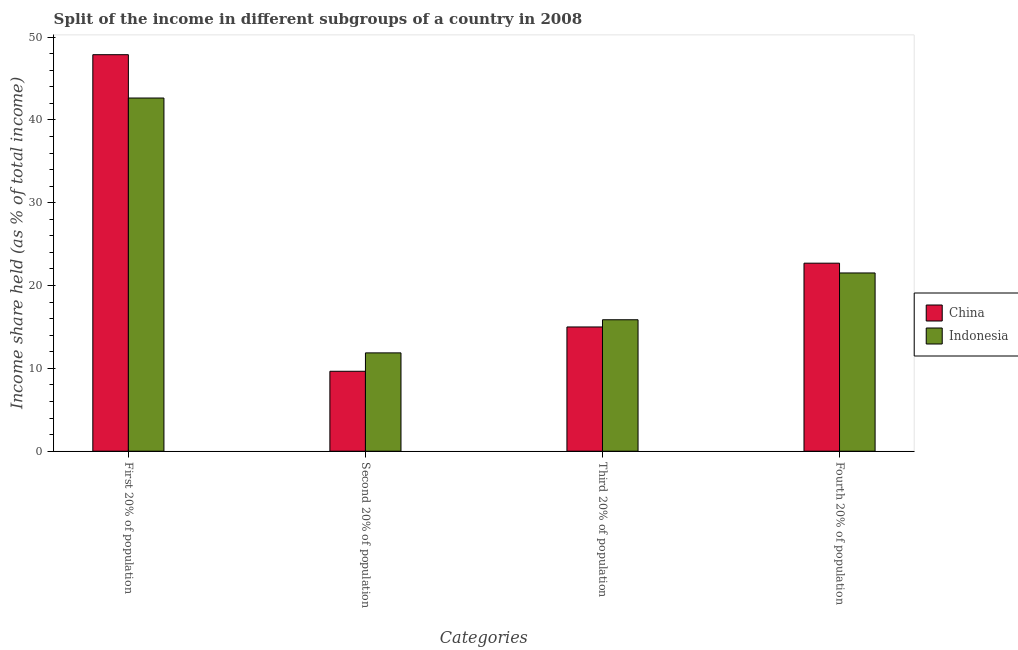How many different coloured bars are there?
Provide a short and direct response. 2. How many groups of bars are there?
Keep it short and to the point. 4. What is the label of the 4th group of bars from the left?
Make the answer very short. Fourth 20% of population. What is the share of the income held by third 20% of the population in Indonesia?
Your answer should be compact. 15.87. Across all countries, what is the maximum share of the income held by third 20% of the population?
Ensure brevity in your answer.  15.87. In which country was the share of the income held by first 20% of the population maximum?
Keep it short and to the point. China. What is the total share of the income held by third 20% of the population in the graph?
Keep it short and to the point. 30.87. What is the difference between the share of the income held by third 20% of the population in Indonesia and that in China?
Offer a very short reply. 0.87. What is the difference between the share of the income held by second 20% of the population in Indonesia and the share of the income held by third 20% of the population in China?
Give a very brief answer. -3.13. What is the average share of the income held by first 20% of the population per country?
Keep it short and to the point. 45.25. What is the difference between the share of the income held by first 20% of the population and share of the income held by fourth 20% of the population in Indonesia?
Give a very brief answer. 21.12. What is the ratio of the share of the income held by third 20% of the population in Indonesia to that in China?
Your answer should be very brief. 1.06. Is the difference between the share of the income held by fourth 20% of the population in Indonesia and China greater than the difference between the share of the income held by third 20% of the population in Indonesia and China?
Offer a very short reply. No. What is the difference between the highest and the second highest share of the income held by second 20% of the population?
Keep it short and to the point. 2.22. What is the difference between the highest and the lowest share of the income held by second 20% of the population?
Provide a short and direct response. 2.22. Is the sum of the share of the income held by first 20% of the population in Indonesia and China greater than the maximum share of the income held by second 20% of the population across all countries?
Your answer should be very brief. Yes. What does the 2nd bar from the left in Second 20% of population represents?
Keep it short and to the point. Indonesia. What does the 1st bar from the right in First 20% of population represents?
Your answer should be compact. Indonesia. Is it the case that in every country, the sum of the share of the income held by first 20% of the population and share of the income held by second 20% of the population is greater than the share of the income held by third 20% of the population?
Provide a short and direct response. Yes. How many bars are there?
Keep it short and to the point. 8. Are all the bars in the graph horizontal?
Keep it short and to the point. No. How many countries are there in the graph?
Make the answer very short. 2. What is the difference between two consecutive major ticks on the Y-axis?
Give a very brief answer. 10. Does the graph contain any zero values?
Ensure brevity in your answer.  No. Does the graph contain grids?
Keep it short and to the point. No. Where does the legend appear in the graph?
Your response must be concise. Center right. How are the legend labels stacked?
Offer a terse response. Vertical. What is the title of the graph?
Ensure brevity in your answer.  Split of the income in different subgroups of a country in 2008. What is the label or title of the X-axis?
Make the answer very short. Categories. What is the label or title of the Y-axis?
Your answer should be very brief. Income share held (as % of total income). What is the Income share held (as % of total income) in China in First 20% of population?
Provide a short and direct response. 47.87. What is the Income share held (as % of total income) of Indonesia in First 20% of population?
Make the answer very short. 42.64. What is the Income share held (as % of total income) of China in Second 20% of population?
Provide a succinct answer. 9.65. What is the Income share held (as % of total income) of Indonesia in Second 20% of population?
Give a very brief answer. 11.87. What is the Income share held (as % of total income) of Indonesia in Third 20% of population?
Offer a very short reply. 15.87. What is the Income share held (as % of total income) of China in Fourth 20% of population?
Offer a terse response. 22.7. What is the Income share held (as % of total income) of Indonesia in Fourth 20% of population?
Provide a short and direct response. 21.52. Across all Categories, what is the maximum Income share held (as % of total income) in China?
Provide a short and direct response. 47.87. Across all Categories, what is the maximum Income share held (as % of total income) of Indonesia?
Offer a very short reply. 42.64. Across all Categories, what is the minimum Income share held (as % of total income) in China?
Provide a succinct answer. 9.65. Across all Categories, what is the minimum Income share held (as % of total income) of Indonesia?
Keep it short and to the point. 11.87. What is the total Income share held (as % of total income) in China in the graph?
Keep it short and to the point. 95.22. What is the total Income share held (as % of total income) of Indonesia in the graph?
Your answer should be compact. 91.9. What is the difference between the Income share held (as % of total income) of China in First 20% of population and that in Second 20% of population?
Give a very brief answer. 38.22. What is the difference between the Income share held (as % of total income) in Indonesia in First 20% of population and that in Second 20% of population?
Keep it short and to the point. 30.77. What is the difference between the Income share held (as % of total income) of China in First 20% of population and that in Third 20% of population?
Provide a succinct answer. 32.87. What is the difference between the Income share held (as % of total income) in Indonesia in First 20% of population and that in Third 20% of population?
Offer a very short reply. 26.77. What is the difference between the Income share held (as % of total income) of China in First 20% of population and that in Fourth 20% of population?
Offer a very short reply. 25.17. What is the difference between the Income share held (as % of total income) of Indonesia in First 20% of population and that in Fourth 20% of population?
Ensure brevity in your answer.  21.12. What is the difference between the Income share held (as % of total income) of China in Second 20% of population and that in Third 20% of population?
Give a very brief answer. -5.35. What is the difference between the Income share held (as % of total income) in China in Second 20% of population and that in Fourth 20% of population?
Offer a terse response. -13.05. What is the difference between the Income share held (as % of total income) of Indonesia in Second 20% of population and that in Fourth 20% of population?
Provide a succinct answer. -9.65. What is the difference between the Income share held (as % of total income) in Indonesia in Third 20% of population and that in Fourth 20% of population?
Your answer should be compact. -5.65. What is the difference between the Income share held (as % of total income) of China in First 20% of population and the Income share held (as % of total income) of Indonesia in Fourth 20% of population?
Offer a terse response. 26.35. What is the difference between the Income share held (as % of total income) in China in Second 20% of population and the Income share held (as % of total income) in Indonesia in Third 20% of population?
Make the answer very short. -6.22. What is the difference between the Income share held (as % of total income) in China in Second 20% of population and the Income share held (as % of total income) in Indonesia in Fourth 20% of population?
Offer a very short reply. -11.87. What is the difference between the Income share held (as % of total income) of China in Third 20% of population and the Income share held (as % of total income) of Indonesia in Fourth 20% of population?
Give a very brief answer. -6.52. What is the average Income share held (as % of total income) of China per Categories?
Your response must be concise. 23.8. What is the average Income share held (as % of total income) of Indonesia per Categories?
Provide a succinct answer. 22.98. What is the difference between the Income share held (as % of total income) in China and Income share held (as % of total income) in Indonesia in First 20% of population?
Make the answer very short. 5.23. What is the difference between the Income share held (as % of total income) in China and Income share held (as % of total income) in Indonesia in Second 20% of population?
Provide a succinct answer. -2.22. What is the difference between the Income share held (as % of total income) of China and Income share held (as % of total income) of Indonesia in Third 20% of population?
Ensure brevity in your answer.  -0.87. What is the difference between the Income share held (as % of total income) in China and Income share held (as % of total income) in Indonesia in Fourth 20% of population?
Your response must be concise. 1.18. What is the ratio of the Income share held (as % of total income) of China in First 20% of population to that in Second 20% of population?
Provide a short and direct response. 4.96. What is the ratio of the Income share held (as % of total income) of Indonesia in First 20% of population to that in Second 20% of population?
Make the answer very short. 3.59. What is the ratio of the Income share held (as % of total income) in China in First 20% of population to that in Third 20% of population?
Offer a very short reply. 3.19. What is the ratio of the Income share held (as % of total income) in Indonesia in First 20% of population to that in Third 20% of population?
Keep it short and to the point. 2.69. What is the ratio of the Income share held (as % of total income) in China in First 20% of population to that in Fourth 20% of population?
Offer a terse response. 2.11. What is the ratio of the Income share held (as % of total income) of Indonesia in First 20% of population to that in Fourth 20% of population?
Offer a terse response. 1.98. What is the ratio of the Income share held (as % of total income) in China in Second 20% of population to that in Third 20% of population?
Keep it short and to the point. 0.64. What is the ratio of the Income share held (as % of total income) in Indonesia in Second 20% of population to that in Third 20% of population?
Your response must be concise. 0.75. What is the ratio of the Income share held (as % of total income) of China in Second 20% of population to that in Fourth 20% of population?
Your answer should be very brief. 0.43. What is the ratio of the Income share held (as % of total income) in Indonesia in Second 20% of population to that in Fourth 20% of population?
Make the answer very short. 0.55. What is the ratio of the Income share held (as % of total income) of China in Third 20% of population to that in Fourth 20% of population?
Make the answer very short. 0.66. What is the ratio of the Income share held (as % of total income) in Indonesia in Third 20% of population to that in Fourth 20% of population?
Your answer should be compact. 0.74. What is the difference between the highest and the second highest Income share held (as % of total income) in China?
Provide a short and direct response. 25.17. What is the difference between the highest and the second highest Income share held (as % of total income) of Indonesia?
Your response must be concise. 21.12. What is the difference between the highest and the lowest Income share held (as % of total income) of China?
Ensure brevity in your answer.  38.22. What is the difference between the highest and the lowest Income share held (as % of total income) of Indonesia?
Your answer should be compact. 30.77. 